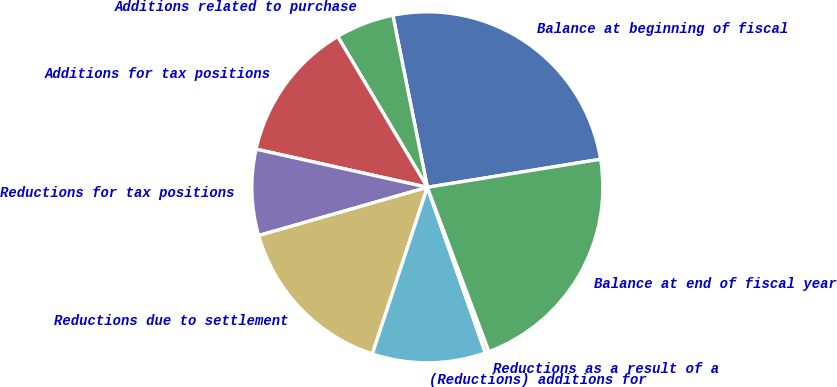Convert chart. <chart><loc_0><loc_0><loc_500><loc_500><pie_chart><fcel>Balance at beginning of fiscal<fcel>Additions related to purchase<fcel>Additions for tax positions<fcel>Reductions for tax positions<fcel>Reductions due to settlement<fcel>(Reductions) additions for<fcel>Reductions as a result of a<fcel>Balance at end of fiscal year<nl><fcel>25.59%<fcel>5.39%<fcel>12.97%<fcel>7.92%<fcel>15.49%<fcel>10.44%<fcel>0.34%<fcel>21.85%<nl></chart> 